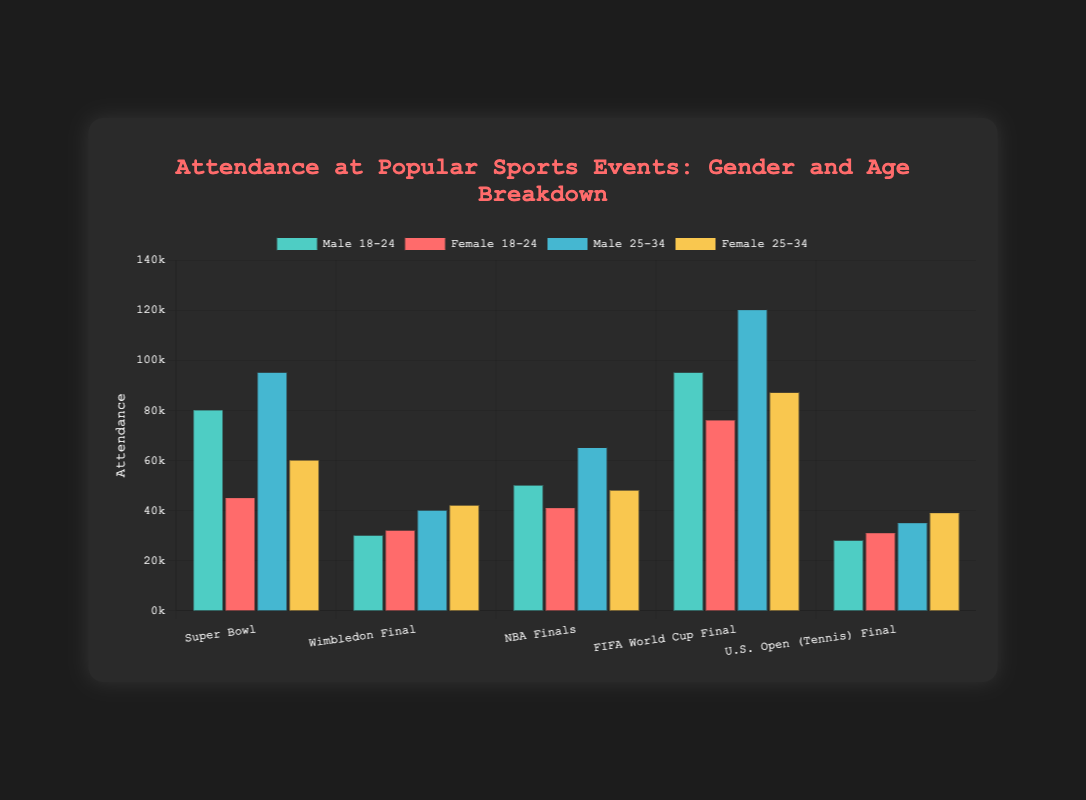Which event has the highest attendance for the male 25-34 age group? The bar corresponding to the FIFA World Cup Final for the male 25-34 age group is the highest among all events in that category, reaching 120,000 attendees.
Answer: FIFA World Cup Final What is the difference in attendance between male 25-34 and female 25-34 for the Super Bowl? The attendance for male 25-34 is 95,000 and for female 25-34 is 60,000. The difference is 95,000 - 60,000.
Answer: 35,000 Which event has the smallest difference in attendance between males and females in the 18-24 age group? By comparing the attendance values, the smallest difference between male and female 18-24 is observed in the Wimbledon Final where the attendance is 30,000 for males and 32,000 for females. The difference is 2,000.
Answer: Wimbledon Final Which demographic group has the lowest attendance for the NBA Finals? The bar for female attendees aged 18-24 is the shortest among all groups for the NBA Finals, indicating an attendance of 41,000.
Answer: Female 18-24 Compare the total attendance of the male 18-24 group across all events with the total attendance of the female 25-34 group across all events. Summing up the attendances: Male 18-24: 80,000 (Super Bowl) + 30,000 (Wimbledon) + 50,000 (NBA) + 95,000 (FIFA) + 28,000 (U.S. Open) = 283,000. Female 25-34: 60,000 (Super Bowl) + 42,000 (Wimbledon) + 48,000 (NBA) + 87,000 (FIFA) + 39,000 (U.S. Open) = 276,000. The total attendance for male 18-24 is 283,000, while for female 25-34 it is 276,000.
Answer: Male 18-24 has higher total attendance For the U.S. Open (Tennis) Final, what is the average attendance across all gender and age groups? Adding up all the attendances for the U.S. Open (Tennis) Final: 28,000 (Male 18-24) + 31,000 (Female 18-24) + 35,000 (Male 25-34) + 39,000 (Female 25-34) = 133,000. The average is 133,000 / 4.
Answer: 33,250 How does the attendance for the Female 18-24 group vary between the FIFA World Cup Final and the Wimbledon Final? The attendance for Female 18-24 is 76,000 for the FIFA World Cup Final and 32,000 for Wimbledon, so it differs by 76,000 - 32,000.
Answer: 44,000 higher in the FIFA World Cup Final What is the combined attendance of all female attendees (18-24 and 25-34) at the Super Bowl? Summing up the female attendances: 45,000 (18-24) + 60,000 (25-34) = 105,000.
Answer: 105,000 Which event shows the greatest difference in attendance between male 18-24 and female 18-24 age groups? The biggest difference between male and female 18-24 attendee numbers is observed in the Super Bowl, where male attendance is 80,000 and female is 45,000, a difference of 35,000.
Answer: Super Bowl 